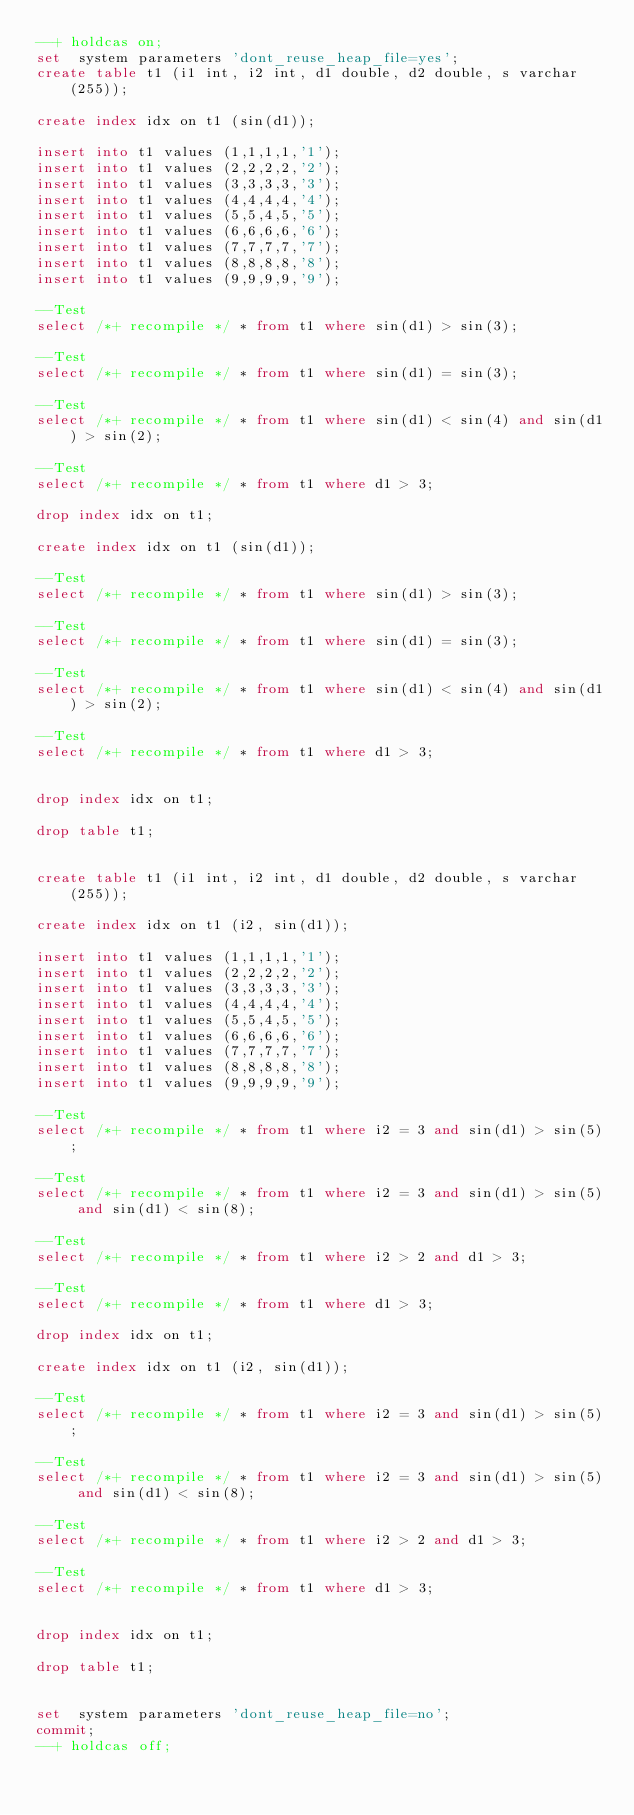Convert code to text. <code><loc_0><loc_0><loc_500><loc_500><_SQL_>--+ holdcas on;
set  system parameters 'dont_reuse_heap_file=yes';
create table t1 (i1 int, i2 int, d1 double, d2 double, s varchar(255));

create index idx on t1 (sin(d1));

insert into t1 values (1,1,1,1,'1');
insert into t1 values (2,2,2,2,'2');
insert into t1 values (3,3,3,3,'3');
insert into t1 values (4,4,4,4,'4');
insert into t1 values (5,5,4,5,'5');
insert into t1 values (6,6,6,6,'6');
insert into t1 values (7,7,7,7,'7');
insert into t1 values (8,8,8,8,'8');
insert into t1 values (9,9,9,9,'9');

--Test
select /*+ recompile */ * from t1 where sin(d1) > sin(3);

--Test
select /*+ recompile */ * from t1 where sin(d1) = sin(3);

--Test
select /*+ recompile */ * from t1 where sin(d1) < sin(4) and sin(d1) > sin(2);

--Test
select /*+ recompile */ * from t1 where d1 > 3;

drop index idx on t1;

create index idx on t1 (sin(d1));

--Test
select /*+ recompile */ * from t1 where sin(d1) > sin(3);

--Test
select /*+ recompile */ * from t1 where sin(d1) = sin(3);

--Test
select /*+ recompile */ * from t1 where sin(d1) < sin(4) and sin(d1) > sin(2);

--Test
select /*+ recompile */ * from t1 where d1 > 3;


drop index idx on t1;

drop table t1;


create table t1 (i1 int, i2 int, d1 double, d2 double, s varchar(255));

create index idx on t1 (i2, sin(d1));

insert into t1 values (1,1,1,1,'1');
insert into t1 values (2,2,2,2,'2');
insert into t1 values (3,3,3,3,'3');
insert into t1 values (4,4,4,4,'4');
insert into t1 values (5,5,4,5,'5');
insert into t1 values (6,6,6,6,'6');
insert into t1 values (7,7,7,7,'7');
insert into t1 values (8,8,8,8,'8');
insert into t1 values (9,9,9,9,'9');

--Test
select /*+ recompile */ * from t1 where i2 = 3 and sin(d1) > sin(5);

--Test
select /*+ recompile */ * from t1 where i2 = 3 and sin(d1) > sin(5) and sin(d1) < sin(8);

--Test
select /*+ recompile */ * from t1 where i2 > 2 and d1 > 3;

--Test
select /*+ recompile */ * from t1 where d1 > 3;

drop index idx on t1;

create index idx on t1 (i2, sin(d1));

--Test
select /*+ recompile */ * from t1 where i2 = 3 and sin(d1) > sin(5);

--Test
select /*+ recompile */ * from t1 where i2 = 3 and sin(d1) > sin(5) and sin(d1) < sin(8);

--Test
select /*+ recompile */ * from t1 where i2 > 2 and d1 > 3;

--Test
select /*+ recompile */ * from t1 where d1 > 3;


drop index idx on t1;

drop table t1;


set  system parameters 'dont_reuse_heap_file=no';
commit;
--+ holdcas off;
</code> 